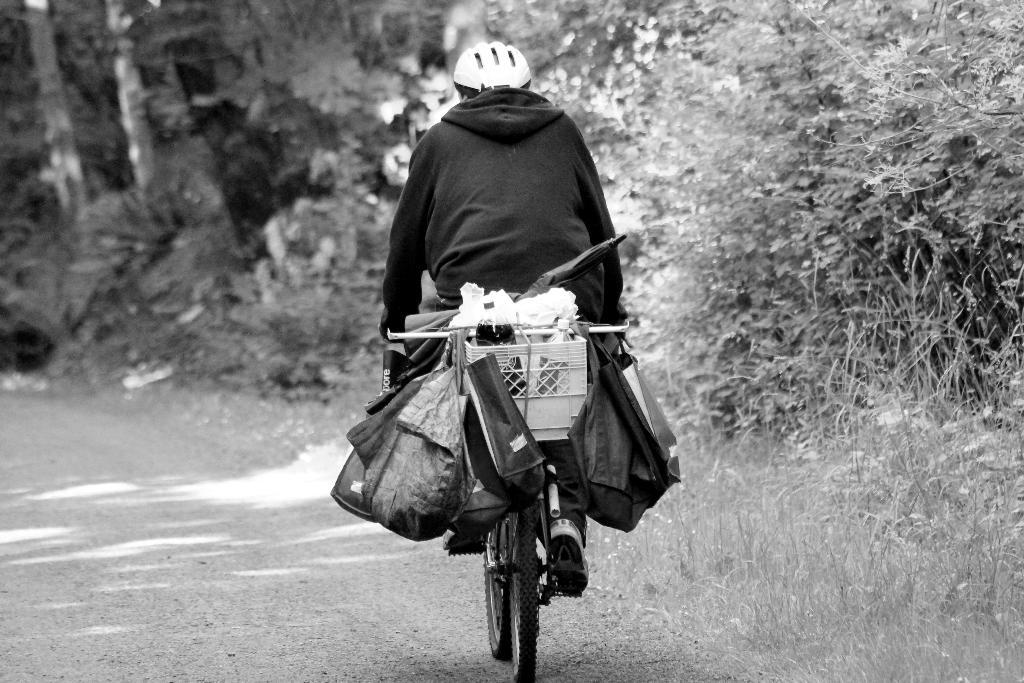What is the main subject of the image? There is a person riding a bicycle in the image. What can be seen on the bicycle? The bicycle has objects on it, and bags are hanging on it. What type of vegetation is on the right side of the image? There are trees on the right side of the image. What is the ground surface like in the image? There is grass visible in the image. What town is the person riding the bicycle through in the image? There is no town visible in the image; it only shows a person riding a bicycle with objects and bags on it, surrounded by trees and grass. How does the servant assist the person riding the bicycle in the image? There is no servant present in the image; it only shows a person riding a bicycle with objects and bags on it, surrounded by trees and grass. 